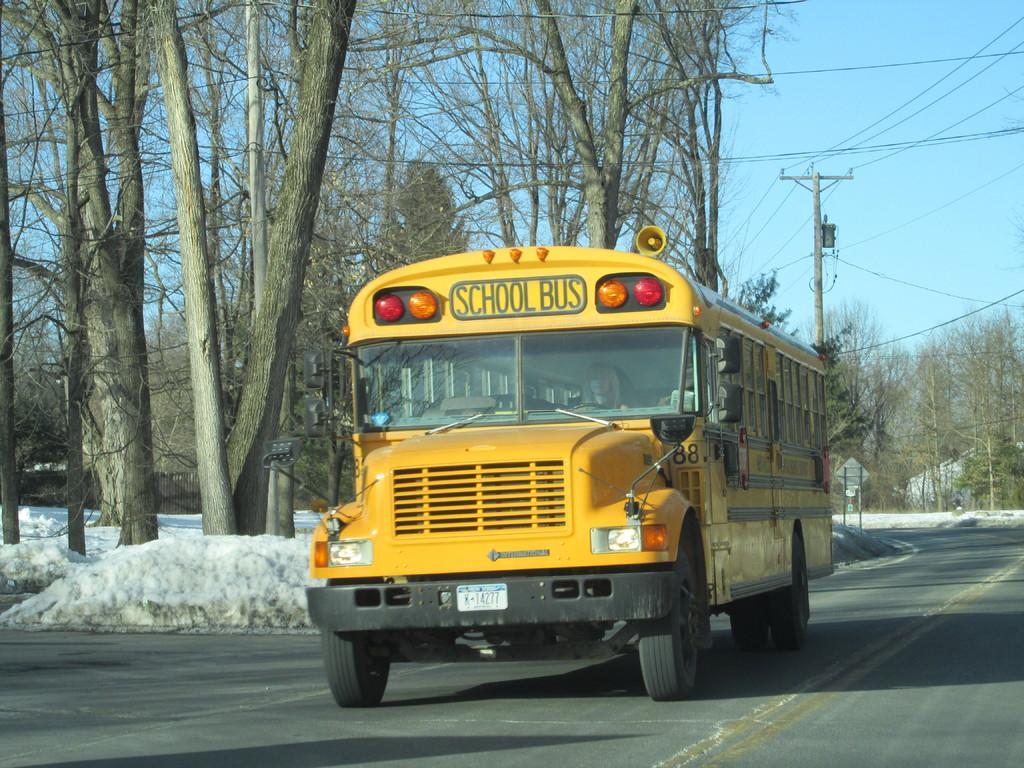Provide a one-sentence caption for the provided image. A yellow school bus on the road during the winter. 